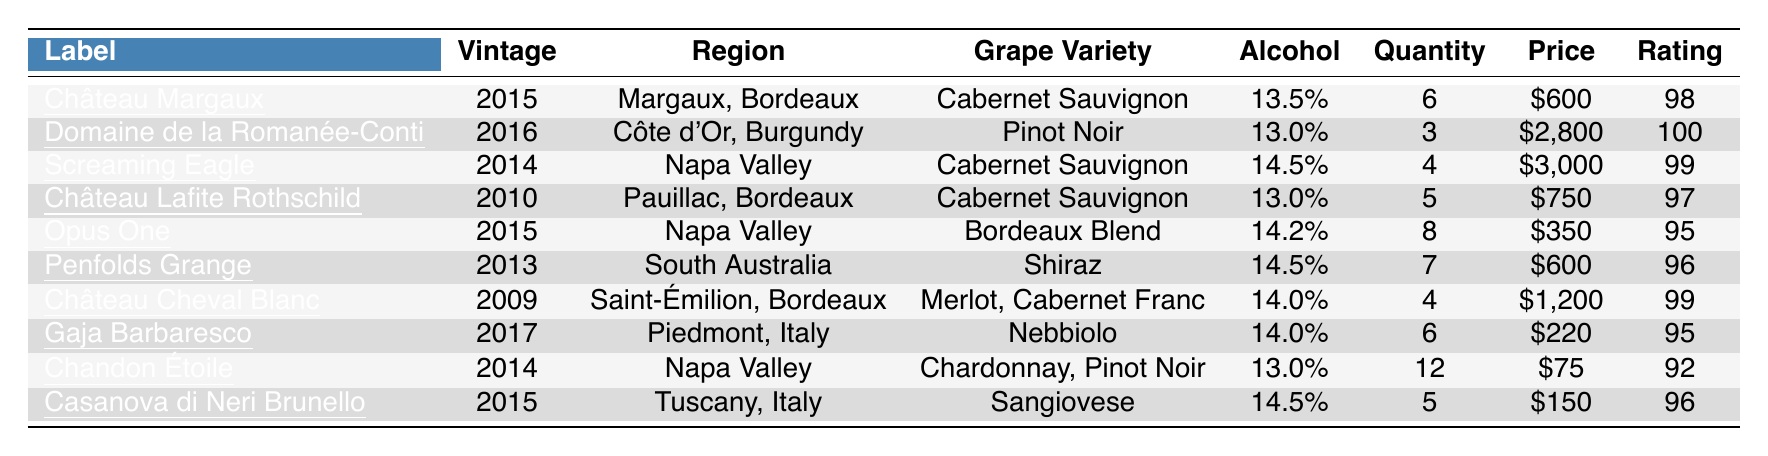What is the highest-rated wine in the collection? By scanning the "Rating" column, Domaine de la Romanée-Conti has a rating of 100, which is the highest in the table.
Answer: Domaine de la Romanée-Conti How many bottles of Château Cheval Blanc are available? Checking the "Quantity" column for Château Cheval Blanc, it lists a quantity of 4 bottles.
Answer: 4 What is the total price of the Opus One wine? The price per bottle of Opus One is $350 and there are 8 bottles. Therefore, the total price is calculated as 350 * 8 = 2800.
Answer: $2800 Is the alcohol content of the Gaja Barbaresco greater than 13%? Looking at the alcohol content in the table, Gaja Barbaresco has an alcohol content of 14.0%, which is indeed greater than 13%.
Answer: Yes What is the average price per bottle of wines from Bordeaux? The Bordeaux wines listed are Château Margaux at $600, Château Lafite Rothschild at $750, and Château Cheval Blanc at $1200. The average price is calculated as (600 + 750 + 1200) / 3 = 850.
Answer: $850 How many bottles of wine have a rating of 95 or above? By counting the entries with ratings of 95 or above, we find that they are Domaine de la Romanée-Conti (100), Screaming Eagle (99), Château Cheval Blanc (99), and Opus One (95), totaling 4 wines.
Answer: 4 What is the difference in rating between the highest and lowest rated wines? The highest rating is 100 (Domaine de la Romanée-Conti) and the lowest rating is 92 (Chandon Étoile). The difference is calculated as 100 - 92 = 8.
Answer: 8 Which wine has the highest price per bottle, and what is that price? Scanning the "Price" column, Screaming Eagle has the highest price at $3000 per bottle.
Answer: Screaming Eagle, $3000 What region does the wine with the lowest alcohol content come from? The wine with the lowest alcohol content is Domaine de la Romanée-Conti at 13.0%, and this wine comes from Côte d'Or, Burgundy, France.
Answer: Côte d'Or, Burgundy, France What is the quantity of wine from Napa Valley? Looking at the two wines from Napa Valley, Opus One (8 bottles) and Screaming Eagle (4 bottles), the total quantity is 8 + 4 = 12.
Answer: 12 